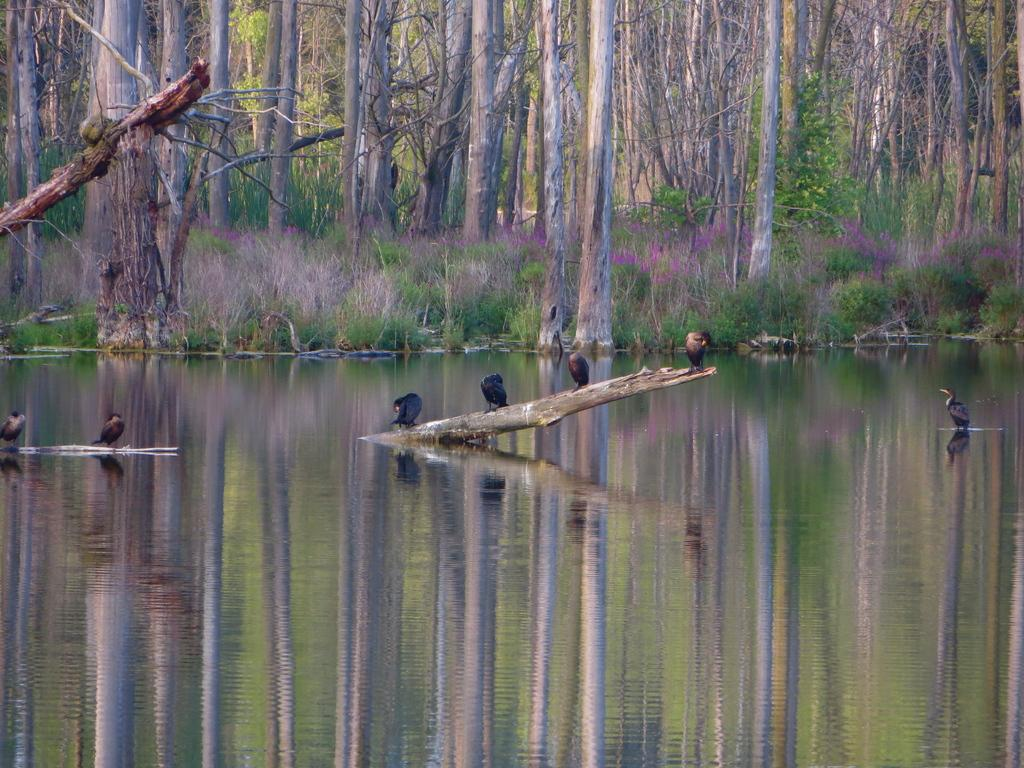What body of water is visible in the image? There is a lake in the image. What type of animals can be seen in the lake? There are birds in the lake. What can be seen in the background of the image? There are trees and grass in the background of the image. What rate of speed are the birds flying at in the image? The rate of speed at which the birds are flying cannot be determined from the image. 